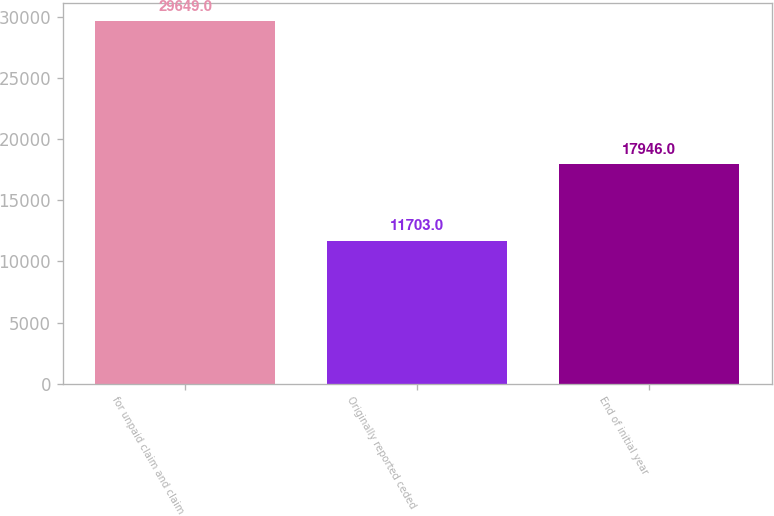Convert chart. <chart><loc_0><loc_0><loc_500><loc_500><bar_chart><fcel>for unpaid claim and claim<fcel>Originally reported ceded<fcel>End of initial year<nl><fcel>29649<fcel>11703<fcel>17946<nl></chart> 